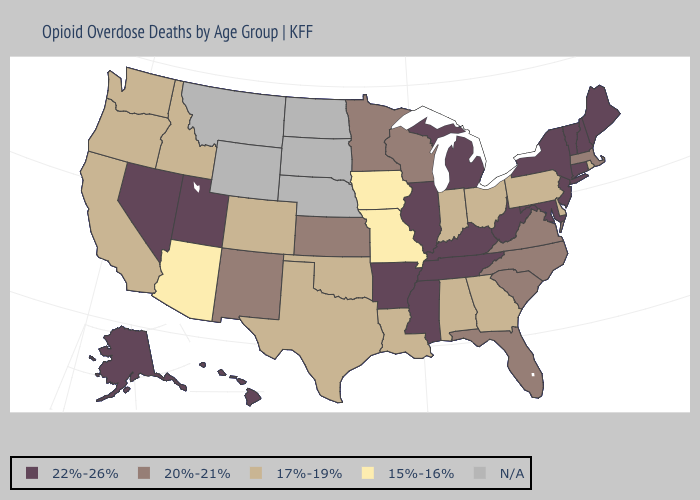Among the states that border California , which have the highest value?
Be succinct. Nevada. Name the states that have a value in the range N/A?
Answer briefly. Montana, Nebraska, North Dakota, South Dakota, Wyoming. Name the states that have a value in the range 22%-26%?
Answer briefly. Alaska, Arkansas, Connecticut, Hawaii, Illinois, Kentucky, Maine, Maryland, Michigan, Mississippi, Nevada, New Hampshire, New Jersey, New York, Tennessee, Utah, Vermont, West Virginia. Is the legend a continuous bar?
Quick response, please. No. Name the states that have a value in the range 20%-21%?
Short answer required. Florida, Kansas, Massachusetts, Minnesota, New Mexico, North Carolina, South Carolina, Virginia, Wisconsin. Does the map have missing data?
Answer briefly. Yes. Does South Carolina have the lowest value in the South?
Quick response, please. No. What is the highest value in the MidWest ?
Concise answer only. 22%-26%. Name the states that have a value in the range 17%-19%?
Short answer required. Alabama, California, Colorado, Delaware, Georgia, Idaho, Indiana, Louisiana, Ohio, Oklahoma, Oregon, Pennsylvania, Rhode Island, Texas, Washington. Which states hav the highest value in the Northeast?
Concise answer only. Connecticut, Maine, New Hampshire, New Jersey, New York, Vermont. Name the states that have a value in the range 17%-19%?
Short answer required. Alabama, California, Colorado, Delaware, Georgia, Idaho, Indiana, Louisiana, Ohio, Oklahoma, Oregon, Pennsylvania, Rhode Island, Texas, Washington. What is the highest value in the USA?
Keep it brief. 22%-26%. How many symbols are there in the legend?
Be succinct. 5. Does New York have the lowest value in the USA?
Short answer required. No. 